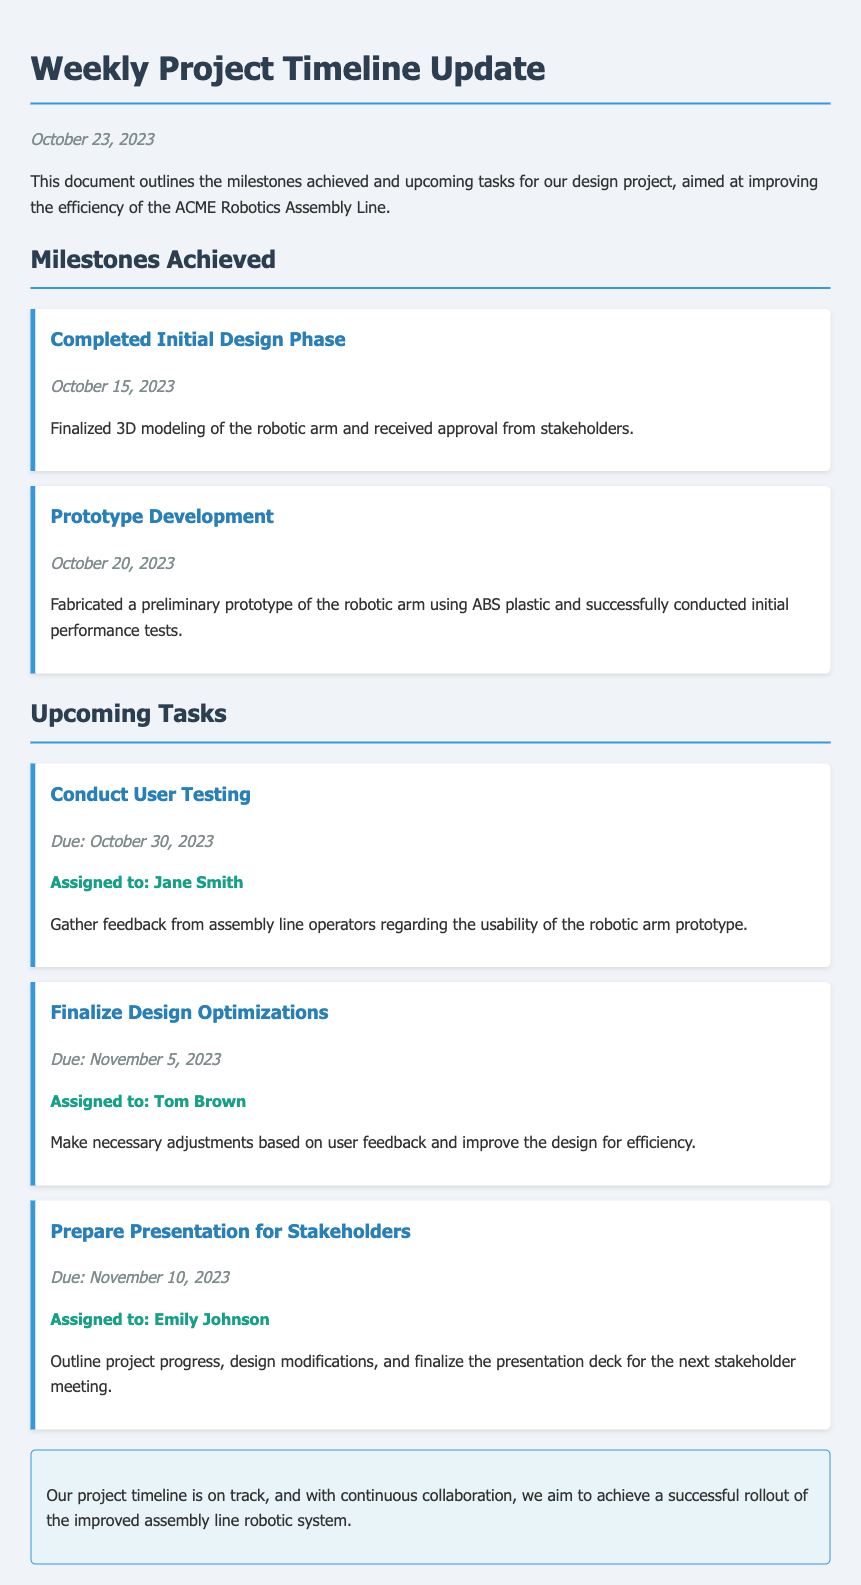What is the date of the document? The date of the document is explicitly stated at the beginning, which is October 23, 2023.
Answer: October 23, 2023 What milestone was completed on October 15, 2023? The milestone achieved on October 15, 2023, is the completion of the Initial Design Phase.
Answer: Completed Initial Design Phase Who is assigned to conduct user testing? The document specifies that Jane Smith is assigned to conduct user testing.
Answer: Jane Smith What is the due date for the task "Finalize Design Optimizations"? The due date for Finalize Design Optimizations is clearly mentioned in the task section, which is November 5, 2023.
Answer: November 5, 2023 How many milestones are listed in the document? The document includes a count of completed milestones, which are two in total.
Answer: 2 What material was used for the preliminary prototype? The document states that ABS plastic was used for fabricating the preliminary prototype of the robotic arm.
Answer: ABS plastic What is the purpose of preparing the presentation for stakeholders? The document indicates that the purpose is to outline project progress, design modifications, and finalize the presentation deck.
Answer: Outline project progress, design modifications When is the next stakeholder meeting presentation due? The due date for the presentation to stakeholders is mentioned as November 10, 2023.
Answer: November 10, 2023 What is the overall status of the project timeline? The document concludes with a positive assessment of the project timeline being on track.
Answer: On track 